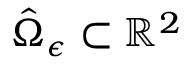<formula> <loc_0><loc_0><loc_500><loc_500>\hat { \Omega } _ { \epsilon } \subset \mathbb { R } ^ { 2 }</formula> 